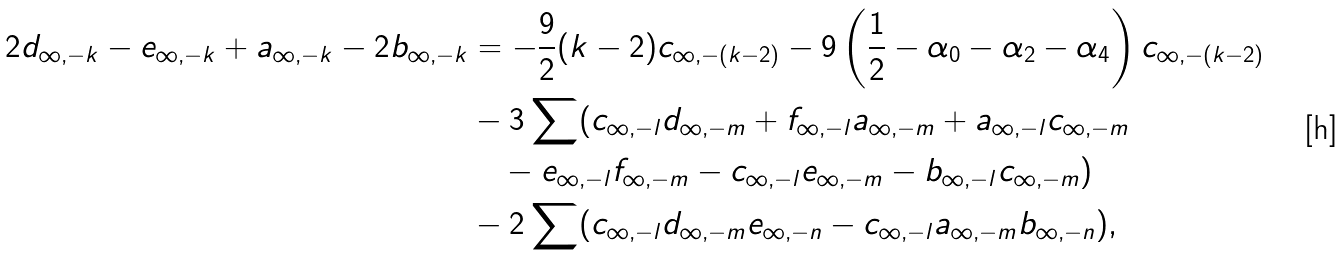<formula> <loc_0><loc_0><loc_500><loc_500>2 d _ { \infty , - k } - e _ { \infty , - k } + a _ { \infty , - k } - 2 b _ { \infty , - k } & = - \frac { 9 } { 2 } ( k - 2 ) c _ { \infty , - ( k - 2 ) } - 9 \left ( \frac { 1 } { 2 } - \alpha _ { 0 } - \alpha _ { 2 } - \alpha _ { 4 } \right ) c _ { \infty , - ( k - 2 ) } \\ & - 3 \sum ( c _ { \infty , - l } d _ { \infty , - m } + f _ { \infty , - l } a _ { \infty , - m } + a _ { \infty , - l } c _ { \infty , - m } \\ & \quad - e _ { \infty , - l } f _ { \infty , - m } - c _ { \infty , - l } e _ { \infty , - m } - b _ { \infty , - l } c _ { \infty , - m } ) \\ & - 2 \sum ( c _ { \infty , - l } d _ { \infty , - m } e _ { \infty , - n } - c _ { \infty , - l } a _ { \infty , - m } b _ { \infty , - n } ) ,</formula> 